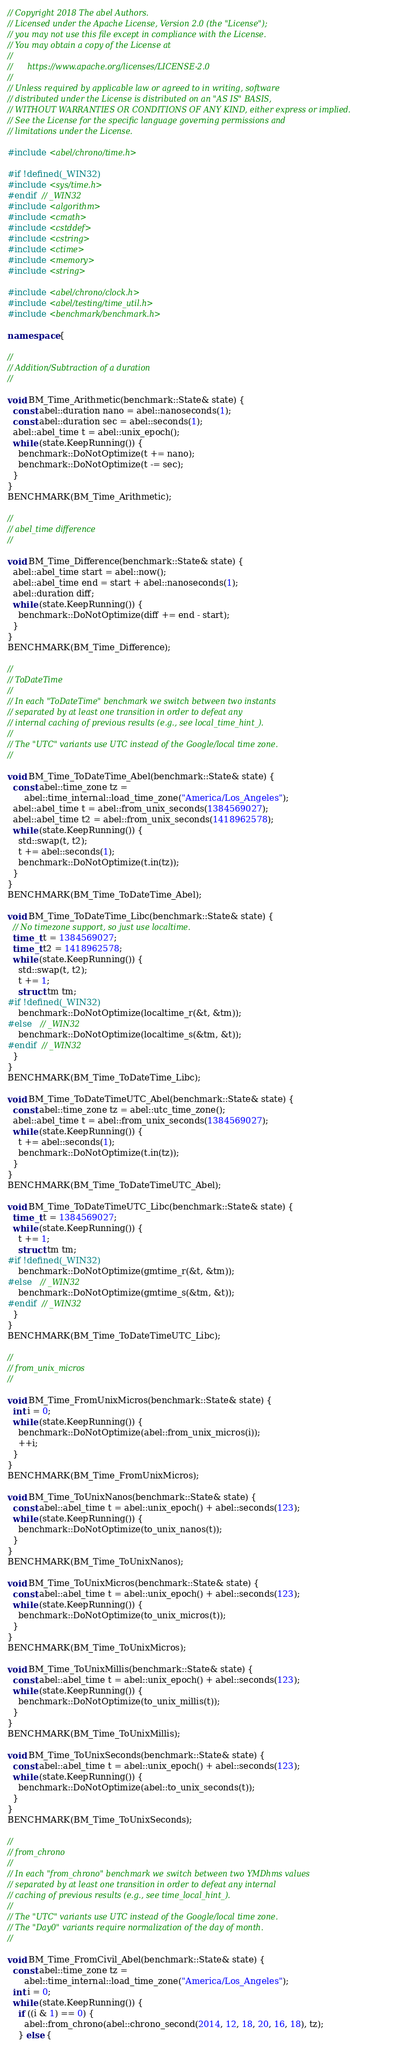<code> <loc_0><loc_0><loc_500><loc_500><_C++_>// Copyright 2018 The abel Authors.
// Licensed under the Apache License, Version 2.0 (the "License");
// you may not use this file except in compliance with the License.
// You may obtain a copy of the License at
//
//      https://www.apache.org/licenses/LICENSE-2.0
//
// Unless required by applicable law or agreed to in writing, software
// distributed under the License is distributed on an "AS IS" BASIS,
// WITHOUT WARRANTIES OR CONDITIONS OF ANY KIND, either express or implied.
// See the License for the specific language governing permissions and
// limitations under the License.

#include <abel/chrono/time.h>

#if !defined(_WIN32)
#include <sys/time.h>
#endif  // _WIN32
#include <algorithm>
#include <cmath>
#include <cstddef>
#include <cstring>
#include <ctime>
#include <memory>
#include <string>

#include <abel/chrono/clock.h>
#include <abel/testing/time_util.h>
#include <benchmark/benchmark.h>

namespace {

//
// Addition/Subtraction of a duration
//

void BM_Time_Arithmetic(benchmark::State& state) {
  const abel::duration nano = abel::nanoseconds(1);
  const abel::duration sec = abel::seconds(1);
  abel::abel_time t = abel::unix_epoch();
  while (state.KeepRunning()) {
    benchmark::DoNotOptimize(t += nano);
    benchmark::DoNotOptimize(t -= sec);
  }
}
BENCHMARK(BM_Time_Arithmetic);

//
// abel_time difference
//

void BM_Time_Difference(benchmark::State& state) {
  abel::abel_time start = abel::now();
  abel::abel_time end = start + abel::nanoseconds(1);
  abel::duration diff;
  while (state.KeepRunning()) {
    benchmark::DoNotOptimize(diff += end - start);
  }
}
BENCHMARK(BM_Time_Difference);

//
// ToDateTime
//
// In each "ToDateTime" benchmark we switch between two instants
// separated by at least one transition in order to defeat any
// internal caching of previous results (e.g., see local_time_hint_).
//
// The "UTC" variants use UTC instead of the Google/local time zone.
//

void BM_Time_ToDateTime_Abel(benchmark::State& state) {
  const abel::time_zone tz =
      abel::time_internal::load_time_zone("America/Los_Angeles");
  abel::abel_time t = abel::from_unix_seconds(1384569027);
  abel::abel_time t2 = abel::from_unix_seconds(1418962578);
  while (state.KeepRunning()) {
    std::swap(t, t2);
    t += abel::seconds(1);
    benchmark::DoNotOptimize(t.in(tz));
  }
}
BENCHMARK(BM_Time_ToDateTime_Abel);

void BM_Time_ToDateTime_Libc(benchmark::State& state) {
  // No timezone support, so just use localtime.
  time_t t = 1384569027;
  time_t t2 = 1418962578;
  while (state.KeepRunning()) {
    std::swap(t, t2);
    t += 1;
    struct tm tm;
#if !defined(_WIN32)
    benchmark::DoNotOptimize(localtime_r(&t, &tm));
#else   // _WIN32
    benchmark::DoNotOptimize(localtime_s(&tm, &t));
#endif  // _WIN32
  }
}
BENCHMARK(BM_Time_ToDateTime_Libc);

void BM_Time_ToDateTimeUTC_Abel(benchmark::State& state) {
  const abel::time_zone tz = abel::utc_time_zone();
  abel::abel_time t = abel::from_unix_seconds(1384569027);
  while (state.KeepRunning()) {
    t += abel::seconds(1);
    benchmark::DoNotOptimize(t.in(tz));
  }
}
BENCHMARK(BM_Time_ToDateTimeUTC_Abel);

void BM_Time_ToDateTimeUTC_Libc(benchmark::State& state) {
  time_t t = 1384569027;
  while (state.KeepRunning()) {
    t += 1;
    struct tm tm;
#if !defined(_WIN32)
    benchmark::DoNotOptimize(gmtime_r(&t, &tm));
#else   // _WIN32
    benchmark::DoNotOptimize(gmtime_s(&tm, &t));
#endif  // _WIN32
  }
}
BENCHMARK(BM_Time_ToDateTimeUTC_Libc);

//
// from_unix_micros
//

void BM_Time_FromUnixMicros(benchmark::State& state) {
  int i = 0;
  while (state.KeepRunning()) {
    benchmark::DoNotOptimize(abel::from_unix_micros(i));
    ++i;
  }
}
BENCHMARK(BM_Time_FromUnixMicros);

void BM_Time_ToUnixNanos(benchmark::State& state) {
  const abel::abel_time t = abel::unix_epoch() + abel::seconds(123);
  while (state.KeepRunning()) {
    benchmark::DoNotOptimize(to_unix_nanos(t));
  }
}
BENCHMARK(BM_Time_ToUnixNanos);

void BM_Time_ToUnixMicros(benchmark::State& state) {
  const abel::abel_time t = abel::unix_epoch() + abel::seconds(123);
  while (state.KeepRunning()) {
    benchmark::DoNotOptimize(to_unix_micros(t));
  }
}
BENCHMARK(BM_Time_ToUnixMicros);

void BM_Time_ToUnixMillis(benchmark::State& state) {
  const abel::abel_time t = abel::unix_epoch() + abel::seconds(123);
  while (state.KeepRunning()) {
    benchmark::DoNotOptimize(to_unix_millis(t));
  }
}
BENCHMARK(BM_Time_ToUnixMillis);

void BM_Time_ToUnixSeconds(benchmark::State& state) {
  const abel::abel_time t = abel::unix_epoch() + abel::seconds(123);
  while (state.KeepRunning()) {
    benchmark::DoNotOptimize(abel::to_unix_seconds(t));
  }
}
BENCHMARK(BM_Time_ToUnixSeconds);

//
// from_chrono
//
// In each "from_chrono" benchmark we switch between two YMDhms values
// separated by at least one transition in order to defeat any internal
// caching of previous results (e.g., see time_local_hint_).
//
// The "UTC" variants use UTC instead of the Google/local time zone.
// The "Day0" variants require normalization of the day of month.
//

void BM_Time_FromCivil_Abel(benchmark::State& state) {
  const abel::time_zone tz =
      abel::time_internal::load_time_zone("America/Los_Angeles");
  int i = 0;
  while (state.KeepRunning()) {
    if ((i & 1) == 0) {
      abel::from_chrono(abel::chrono_second(2014, 12, 18, 20, 16, 18), tz);
    } else {</code> 